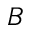Convert formula to latex. <formula><loc_0><loc_0><loc_500><loc_500>B</formula> 